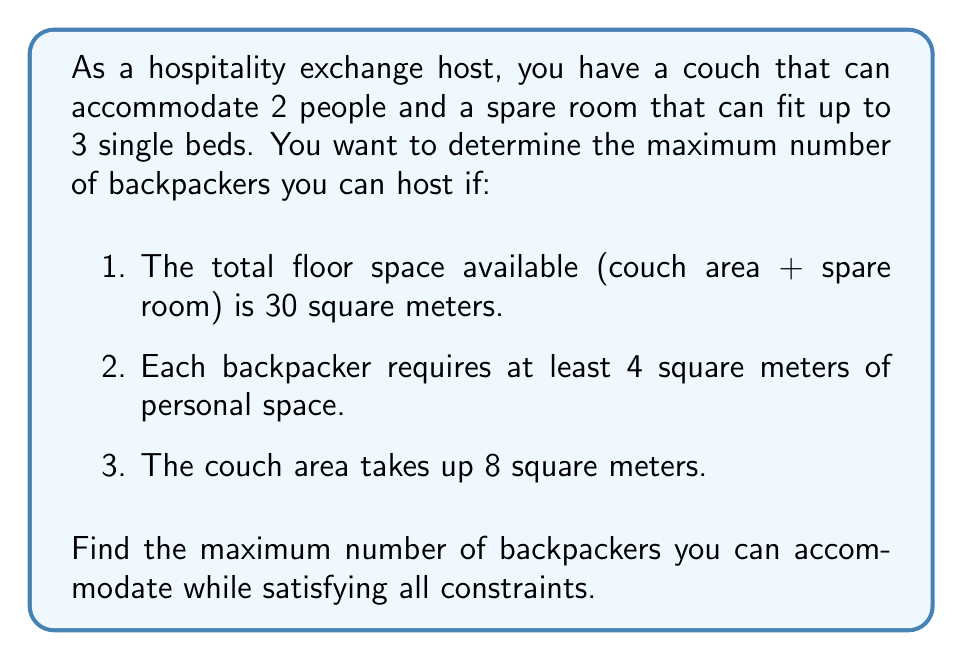Provide a solution to this math problem. Let's approach this step-by-step:

1) First, let's define our variables:
   $x$ = number of backpackers on the couch
   $y$ = number of backpackers in the spare room

2) We know that $x \leq 2$ (couch capacity) and $y \leq 3$ (spare room capacity).

3) The total number of backpackers is $x + y$, which we want to maximize.

4) Now, let's consider the space constraint:
   - Total space = 30 sq meters
   - Couch area = 8 sq meters
   - Spare room area = 30 - 8 = 22 sq meters

5) Each backpacker needs at least 4 sq meters. So:
   $4x + 4y \leq 30$

6) Simplifying:
   $x + y \leq \frac{30}{4} = 7.5$

7) Since $x$ and $y$ must be integers, this means $x + y \leq 7$

8) Now we have a system of inequalities:
   $x + y \leq 7$
   $x \leq 2$
   $y \leq 3$
   $x, y \geq 0$ and integers

9) To maximize $x + y$, we need to choose the largest possible values for $x$ and $y$ that satisfy all constraints.

10) The optimal solution is $x = 2$ and $y = 3$, which gives a total of 5 backpackers.

This solution satisfies all constraints:
- 2 on the couch, 3 in the spare room
- Total space used: $8 + (3 * 4) = 20$ sq meters, which is less than 30
- Each person has at least 4 sq meters of space
Answer: The maximum number of backpackers that can be accommodated is 5. 